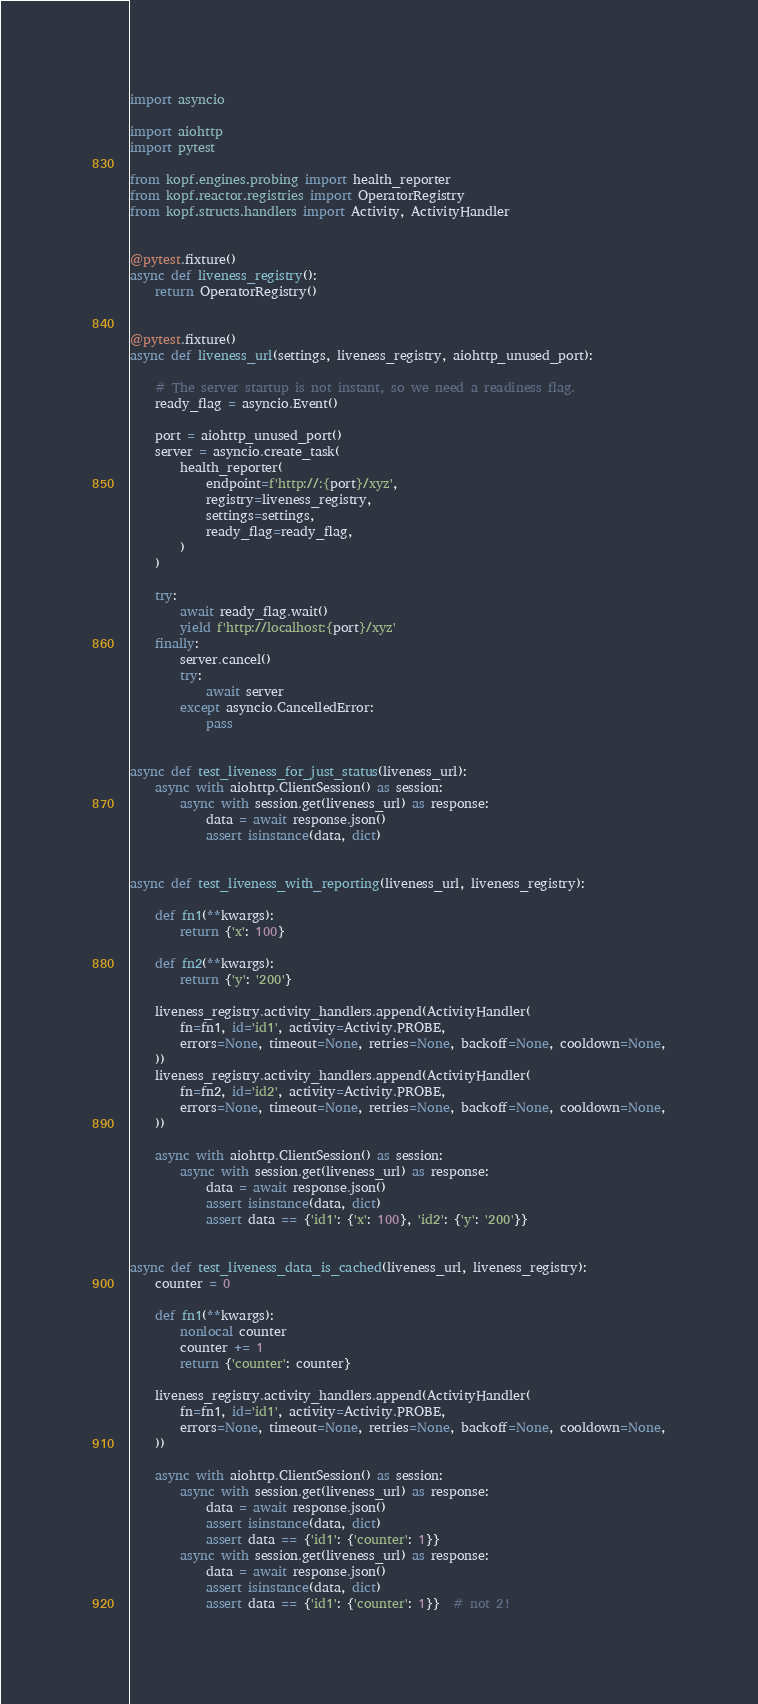Convert code to text. <code><loc_0><loc_0><loc_500><loc_500><_Python_>import asyncio

import aiohttp
import pytest

from kopf.engines.probing import health_reporter
from kopf.reactor.registries import OperatorRegistry
from kopf.structs.handlers import Activity, ActivityHandler


@pytest.fixture()
async def liveness_registry():
    return OperatorRegistry()


@pytest.fixture()
async def liveness_url(settings, liveness_registry, aiohttp_unused_port):

    # The server startup is not instant, so we need a readiness flag.
    ready_flag = asyncio.Event()

    port = aiohttp_unused_port()
    server = asyncio.create_task(
        health_reporter(
            endpoint=f'http://:{port}/xyz',
            registry=liveness_registry,
            settings=settings,
            ready_flag=ready_flag,
        )
    )

    try:
        await ready_flag.wait()
        yield f'http://localhost:{port}/xyz'
    finally:
        server.cancel()
        try:
            await server
        except asyncio.CancelledError:
            pass


async def test_liveness_for_just_status(liveness_url):
    async with aiohttp.ClientSession() as session:
        async with session.get(liveness_url) as response:
            data = await response.json()
            assert isinstance(data, dict)


async def test_liveness_with_reporting(liveness_url, liveness_registry):

    def fn1(**kwargs):
        return {'x': 100}

    def fn2(**kwargs):
        return {'y': '200'}

    liveness_registry.activity_handlers.append(ActivityHandler(
        fn=fn1, id='id1', activity=Activity.PROBE,
        errors=None, timeout=None, retries=None, backoff=None, cooldown=None,
    ))
    liveness_registry.activity_handlers.append(ActivityHandler(
        fn=fn2, id='id2', activity=Activity.PROBE,
        errors=None, timeout=None, retries=None, backoff=None, cooldown=None,
    ))

    async with aiohttp.ClientSession() as session:
        async with session.get(liveness_url) as response:
            data = await response.json()
            assert isinstance(data, dict)
            assert data == {'id1': {'x': 100}, 'id2': {'y': '200'}}


async def test_liveness_data_is_cached(liveness_url, liveness_registry):
    counter = 0

    def fn1(**kwargs):
        nonlocal counter
        counter += 1
        return {'counter': counter}

    liveness_registry.activity_handlers.append(ActivityHandler(
        fn=fn1, id='id1', activity=Activity.PROBE,
        errors=None, timeout=None, retries=None, backoff=None, cooldown=None,
    ))

    async with aiohttp.ClientSession() as session:
        async with session.get(liveness_url) as response:
            data = await response.json()
            assert isinstance(data, dict)
            assert data == {'id1': {'counter': 1}}
        async with session.get(liveness_url) as response:
            data = await response.json()
            assert isinstance(data, dict)
            assert data == {'id1': {'counter': 1}}  # not 2!
</code> 